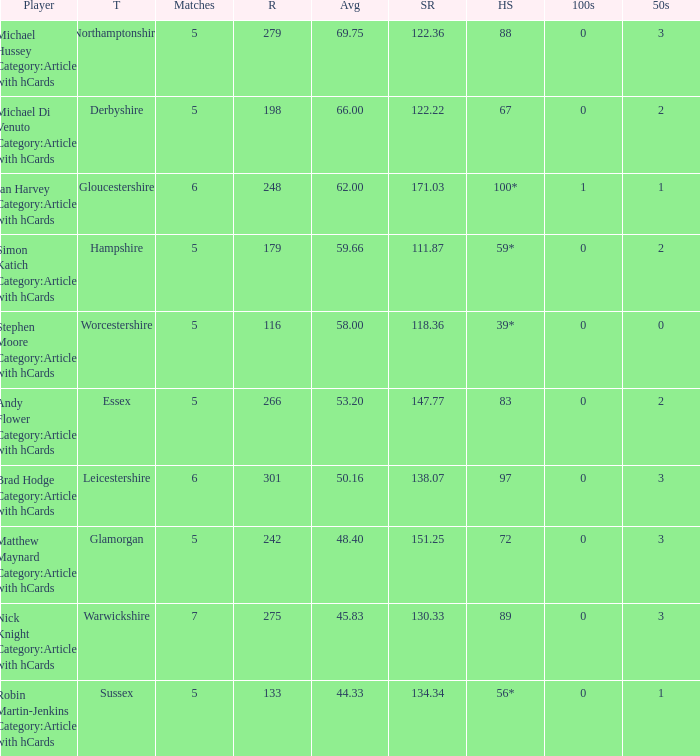What is the smallest amount of matches? 5.0. 